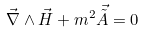Convert formula to latex. <formula><loc_0><loc_0><loc_500><loc_500>\vec { \nabla } \wedge \vec { H } + m ^ { 2 } \vec { \tilde { A } } = 0</formula> 